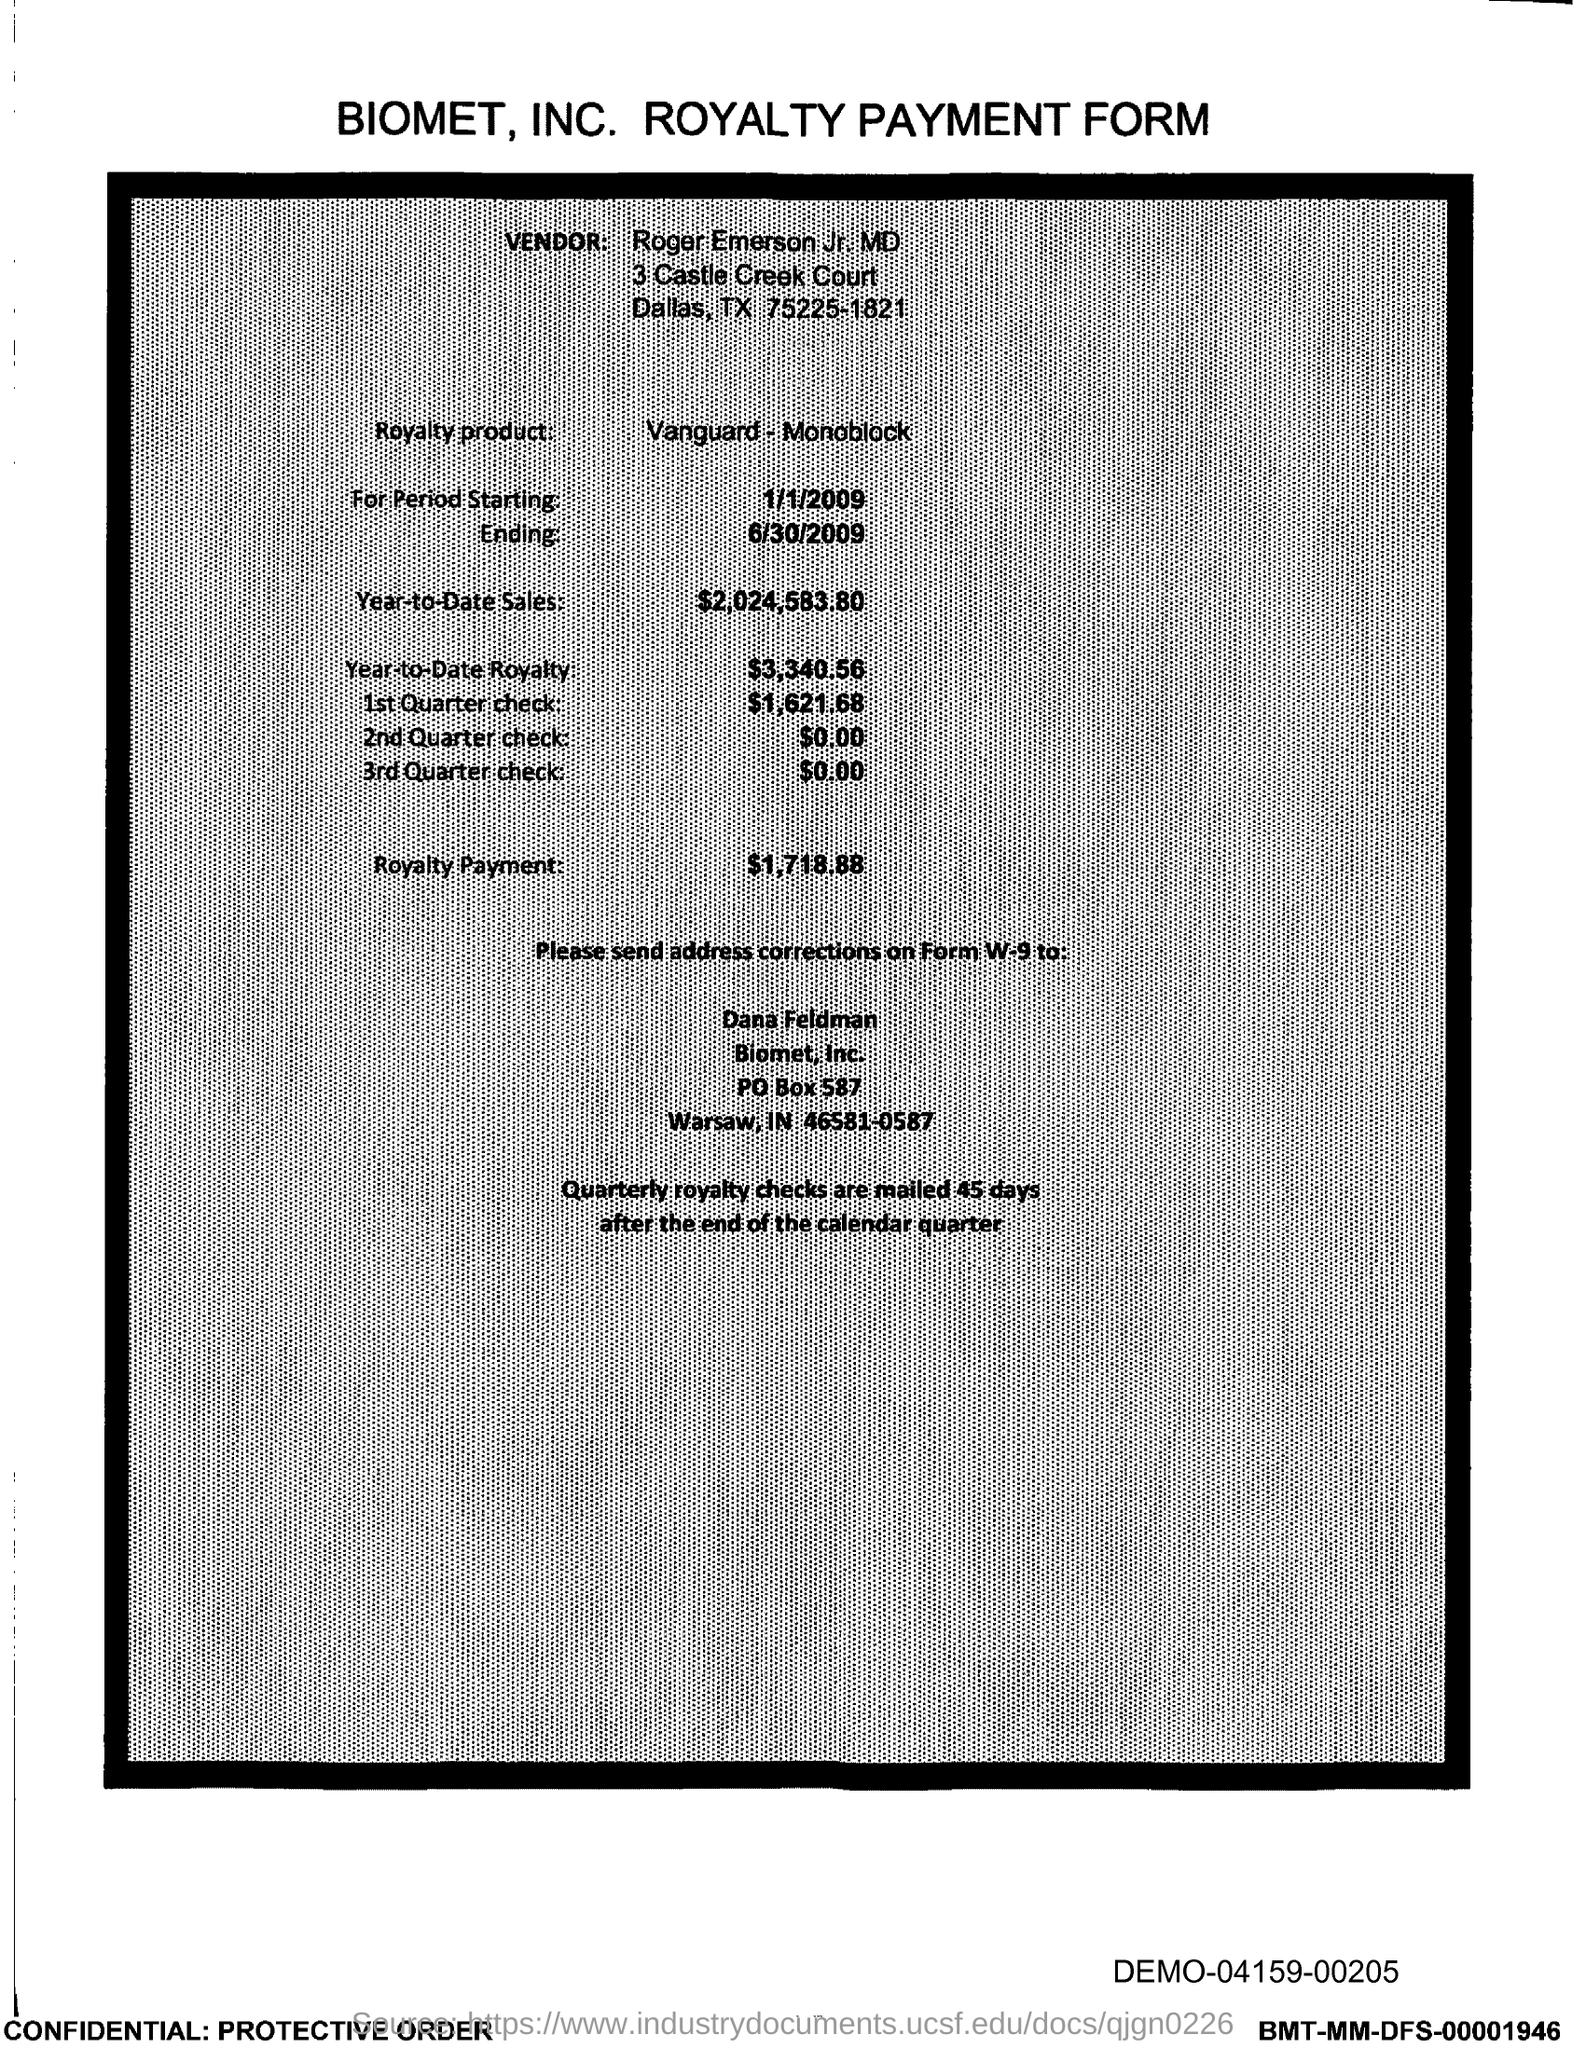Which company's royalty payment form is this?
Provide a succinct answer. BIOMET, INC. What is the vendor name given in the form?
Make the answer very short. Roger Emerson Jr, MD. What is the royalty product given in the form?
Give a very brief answer. Vanguard-Monoblock. What is the Year-to-Date Sales of the royalty product?
Provide a succinct answer. $2,024,583.80. What is the Year-to-Date royalty of the product?
Provide a succinct answer. $3,340.56. When are the quartely royalty checks mailed?
Offer a terse response. 45 days after the end of the calendar quarter. What is the amount of 3rd Quarter check given in the form?
Ensure brevity in your answer.  $0.00. What is the amount of 2nd Quarter check mentioned in the form?
Provide a succinct answer. $0.00. What is the amount of 1st quarter check mentioned in the form?
Provide a succinct answer. $1,621.68. What is the royalty payment amount of the product?
Provide a short and direct response. $1,718.88. 